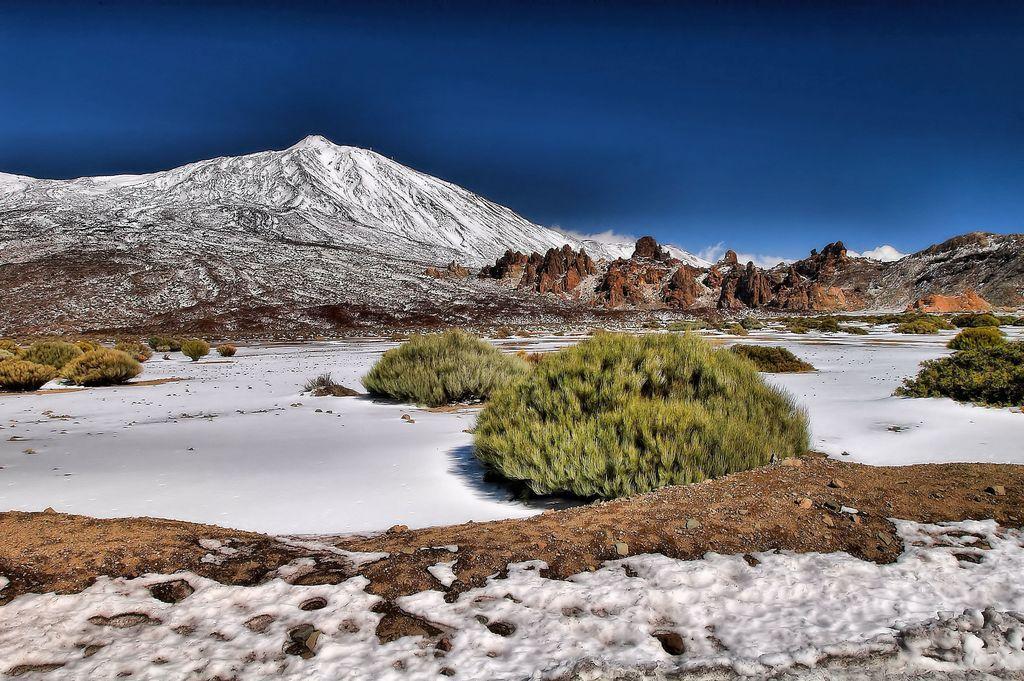How would you summarize this image in a sentence or two? In this image there are hills, blue sky, plants, rocks and snow. 